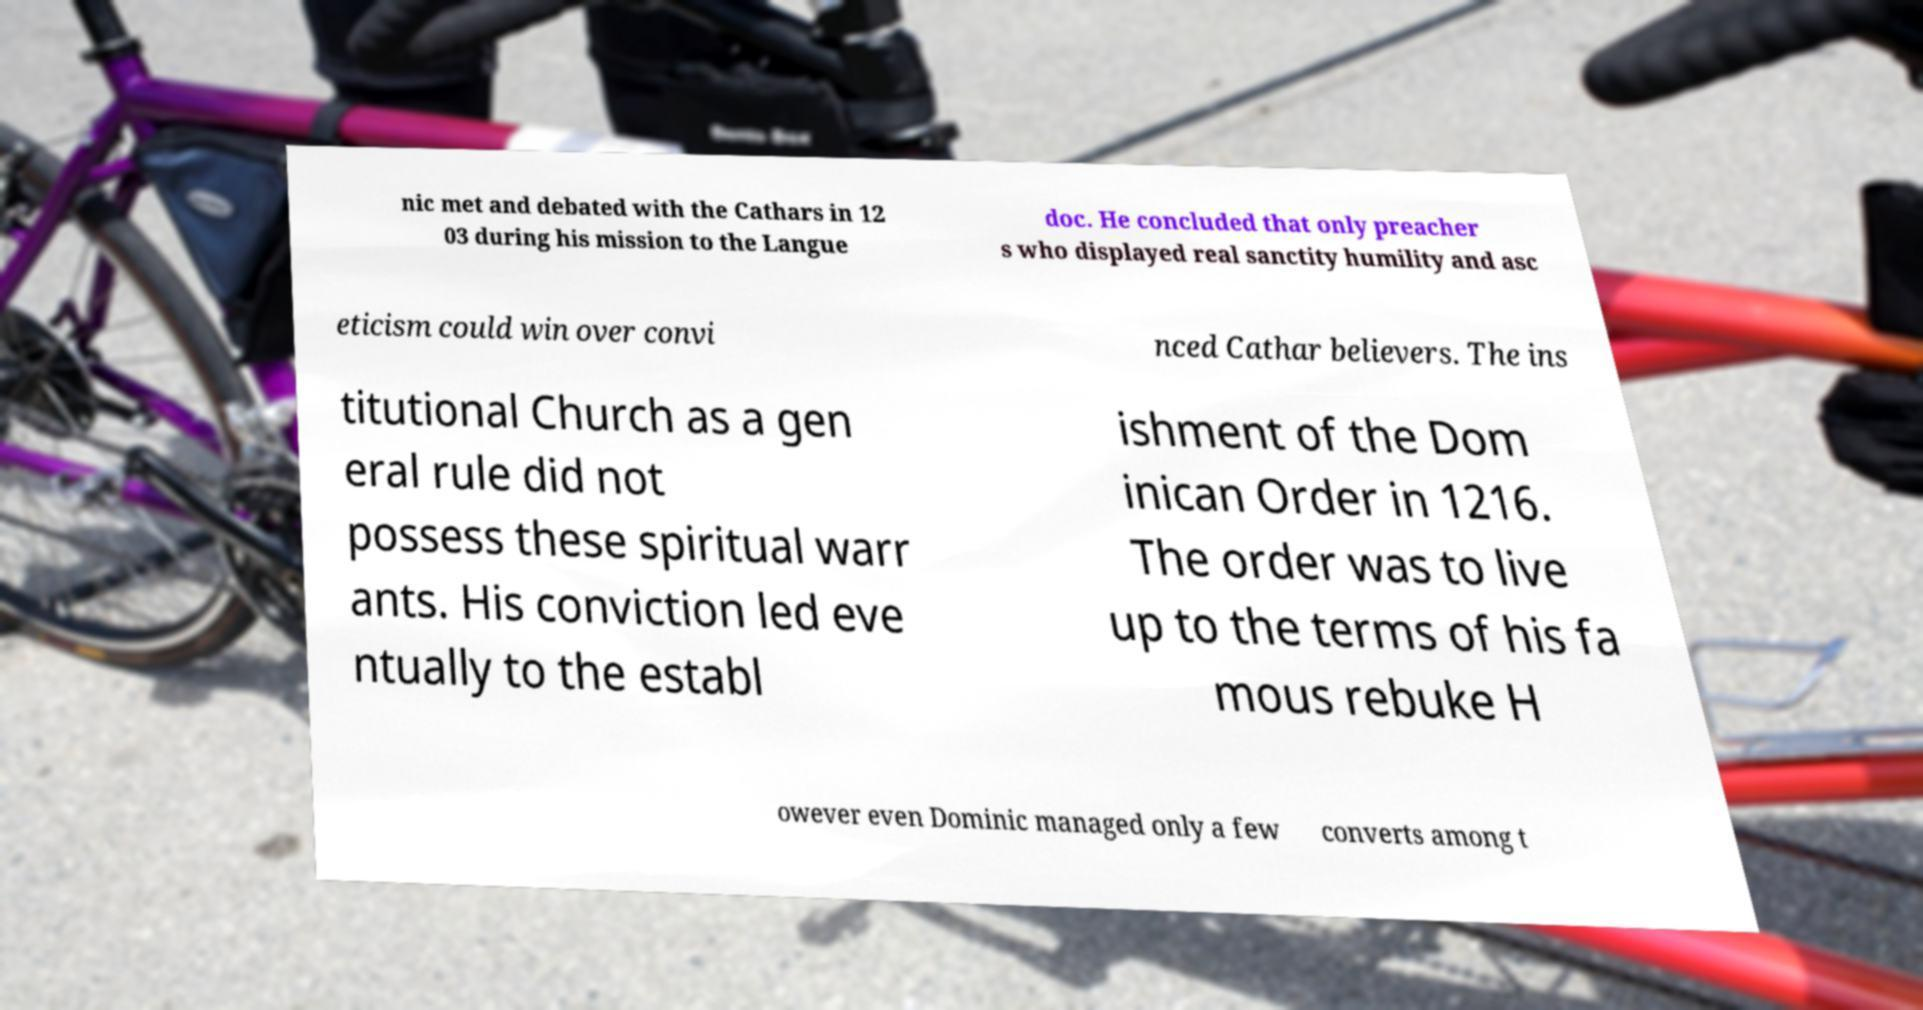Can you read and provide the text displayed in the image?This photo seems to have some interesting text. Can you extract and type it out for me? nic met and debated with the Cathars in 12 03 during his mission to the Langue doc. He concluded that only preacher s who displayed real sanctity humility and asc eticism could win over convi nced Cathar believers. The ins titutional Church as a gen eral rule did not possess these spiritual warr ants. His conviction led eve ntually to the establ ishment of the Dom inican Order in 1216. The order was to live up to the terms of his fa mous rebuke H owever even Dominic managed only a few converts among t 